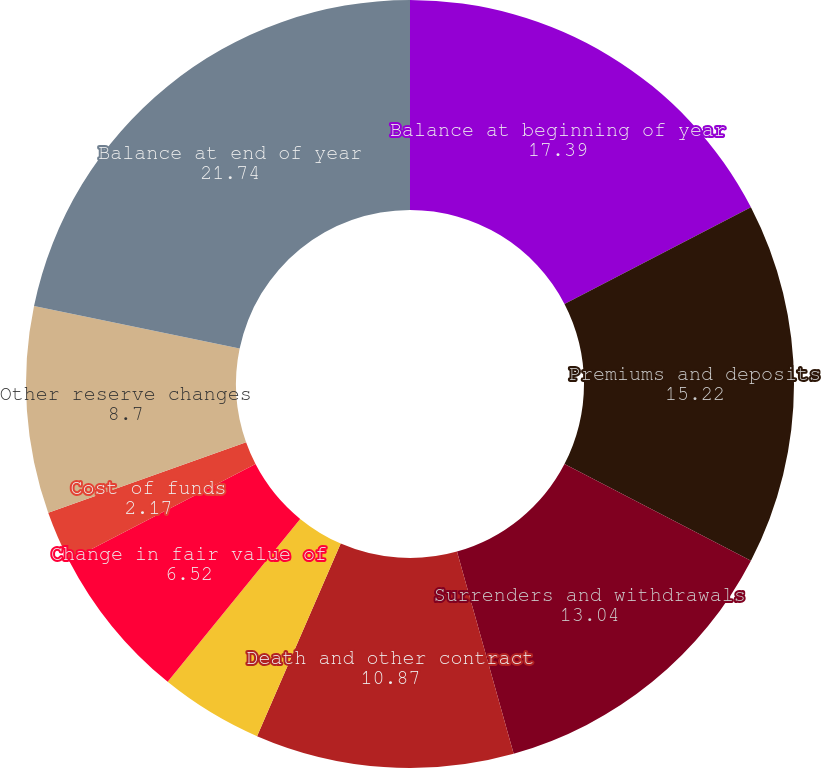Convert chart. <chart><loc_0><loc_0><loc_500><loc_500><pie_chart><fcel>Balance at beginning of year<fcel>Premiums and deposits<fcel>Surrenders and withdrawals<fcel>Death and other contract<fcel>Subtotal<fcel>Change in fair value of<fcel>Cost of funds<fcel>Other reserve changes<fcel>Balance at end of year<fcel>Reinsurance ceded<nl><fcel>17.39%<fcel>15.22%<fcel>13.04%<fcel>10.87%<fcel>4.35%<fcel>6.52%<fcel>2.17%<fcel>8.7%<fcel>21.74%<fcel>0.0%<nl></chart> 